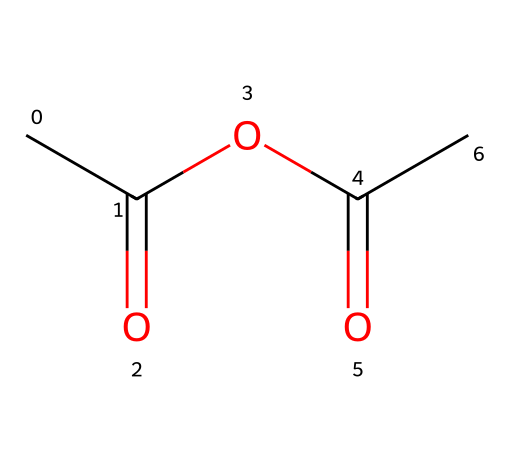What is the chemical name of this compound? The SMILES representation indicates that the compound consists of two acyl groups and an alkoxy link, which characterizes it as acetic anhydride.
Answer: acetic anhydride How many carbon atoms are present in the structure? By analyzing the SMILES representation, there are four carbon atoms in total, as denoted by 'CC' and 'C' in the structure.
Answer: four What type of functional groups are present in acetic anhydride? The structure contains two acyl groups (carbonyls) and an ether linkage, which are characteristic of acid anhydrides.
Answer: acyl groups and ether How many oxygen atoms are found in this molecule? Reviewing the SMILES, there are three oxygen atoms indicated by the 'O' symbols within the structure.
Answer: three What is the valence count around each carbon atom? Analyzing the structure, each carbon has four valencies satisfied, with double bonds to oxygen and single bonds to other carbons.
Answer: four What type of reaction typically uses acetic anhydride? Acetic anhydride is commonly used in acetylation reactions, where it reacts with various substrates to introduce acetyl groups.
Answer: acetylation Is this compound miscible in water? Acetic anhydride has limited solubility in water as it tends to hydrolyze, producing acetic acid.
Answer: limited 